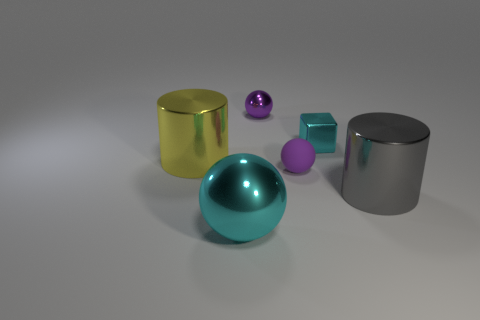There is a rubber object that is the same color as the small shiny ball; what is its size?
Offer a very short reply. Small. Are there an equal number of small shiny blocks that are behind the small block and small blocks that are to the left of the yellow shiny cylinder?
Make the answer very short. Yes. How many spheres are tiny purple objects or matte things?
Provide a short and direct response. 2. How many tiny cyan blocks have the same material as the yellow thing?
Keep it short and to the point. 1. There is a large shiny thing that is the same color as the small shiny block; what shape is it?
Your answer should be compact. Sphere. There is a tiny object that is left of the cyan shiny cube and right of the small purple metallic ball; what is its material?
Offer a very short reply. Rubber. There is a small cyan thing that is right of the purple metal object; what shape is it?
Give a very brief answer. Cube. The big thing right of the ball that is behind the cyan cube is what shape?
Provide a succinct answer. Cylinder. Are there any blue metallic objects of the same shape as the tiny cyan shiny object?
Your response must be concise. No. There is a gray object that is the same size as the yellow metallic thing; what shape is it?
Provide a succinct answer. Cylinder. 